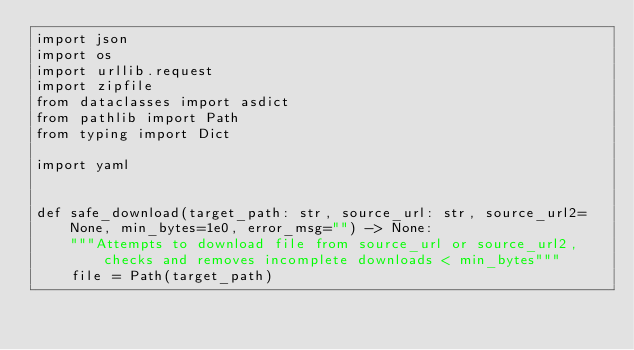Convert code to text. <code><loc_0><loc_0><loc_500><loc_500><_Python_>import json
import os
import urllib.request
import zipfile
from dataclasses import asdict
from pathlib import Path
from typing import Dict

import yaml


def safe_download(target_path: str, source_url: str, source_url2=None, min_bytes=1e0, error_msg="") -> None:
    """Attempts to download file from source_url or source_url2, checks and removes incomplete downloads < min_bytes"""
    file = Path(target_path)</code> 